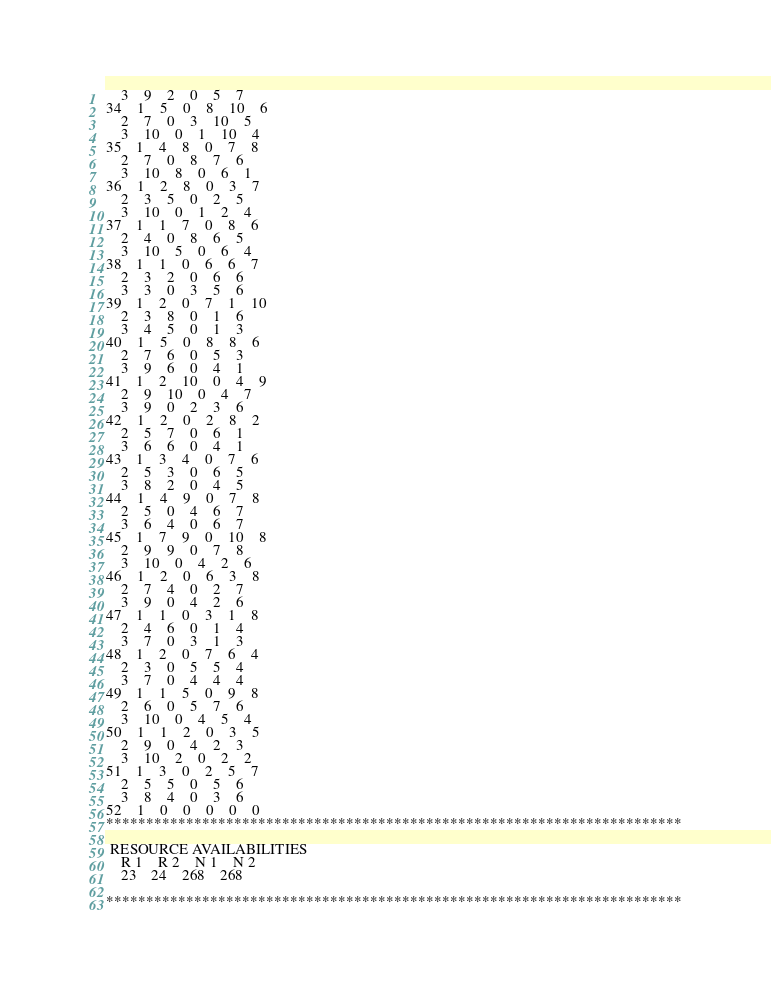Convert code to text. <code><loc_0><loc_0><loc_500><loc_500><_ObjectiveC_>	3	9	2	0	5	7	
34	1	5	0	8	10	6	
	2	7	0	3	10	5	
	3	10	0	1	10	4	
35	1	4	8	0	7	8	
	2	7	0	8	7	6	
	3	10	8	0	6	1	
36	1	2	8	0	3	7	
	2	3	5	0	2	5	
	3	10	0	1	2	4	
37	1	1	7	0	8	6	
	2	4	0	8	6	5	
	3	10	5	0	6	4	
38	1	1	0	6	6	7	
	2	3	2	0	6	6	
	3	3	0	3	5	6	
39	1	2	0	7	1	10	
	2	3	8	0	1	6	
	3	4	5	0	1	3	
40	1	5	0	8	8	6	
	2	7	6	0	5	3	
	3	9	6	0	4	1	
41	1	2	10	0	4	9	
	2	9	10	0	4	7	
	3	9	0	2	3	6	
42	1	2	0	2	8	2	
	2	5	7	0	6	1	
	3	6	6	0	4	1	
43	1	3	4	0	7	6	
	2	5	3	0	6	5	
	3	8	2	0	4	5	
44	1	4	9	0	7	8	
	2	5	0	4	6	7	
	3	6	4	0	6	7	
45	1	7	9	0	10	8	
	2	9	9	0	7	8	
	3	10	0	4	2	6	
46	1	2	0	6	3	8	
	2	7	4	0	2	7	
	3	9	0	4	2	6	
47	1	1	0	3	1	8	
	2	4	6	0	1	4	
	3	7	0	3	1	3	
48	1	2	0	7	6	4	
	2	3	0	5	5	4	
	3	7	0	4	4	4	
49	1	1	5	0	9	8	
	2	6	0	5	7	6	
	3	10	0	4	5	4	
50	1	1	2	0	3	5	
	2	9	0	4	2	3	
	3	10	2	0	2	2	
51	1	3	0	2	5	7	
	2	5	5	0	5	6	
	3	8	4	0	3	6	
52	1	0	0	0	0	0	
************************************************************************

 RESOURCE AVAILABILITIES 
	R 1	R 2	N 1	N 2
	23	24	268	268

************************************************************************
</code> 